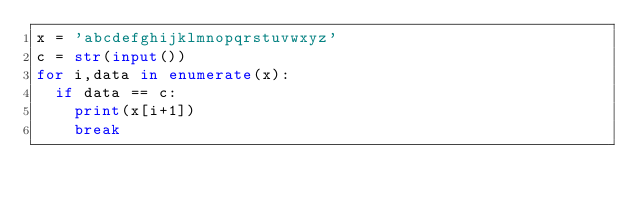<code> <loc_0><loc_0><loc_500><loc_500><_Python_>x = 'abcdefghijklmnopqrstuvwxyz'
c = str(input())
for i,data in enumerate(x):
  if data == c:
    print(x[i+1])
    break</code> 